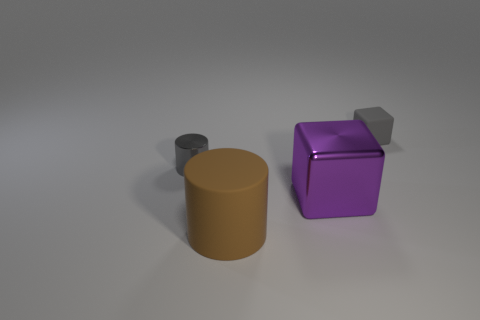Is the number of purple cubes behind the gray cube greater than the number of big metallic things behind the big purple object?
Keep it short and to the point. No. How many metal objects are either red spheres or cylinders?
Give a very brief answer. 1. There is a tiny thing that is the same color as the small matte cube; what is its material?
Offer a terse response. Metal. Are there fewer small gray objects that are behind the small rubber cube than gray metallic objects to the right of the gray metallic cylinder?
Your response must be concise. No. How many things are either cylinders or cylinders that are in front of the purple thing?
Offer a very short reply. 2. What is the material of the gray object that is the same size as the shiny cylinder?
Your answer should be very brief. Rubber. Are the large block and the brown cylinder made of the same material?
Provide a short and direct response. No. What is the color of the object that is both behind the metal cube and to the left of the small gray rubber block?
Provide a succinct answer. Gray. There is a matte object in front of the matte cube; does it have the same color as the small matte cube?
Your answer should be very brief. No. The gray thing that is the same size as the gray matte cube is what shape?
Provide a short and direct response. Cylinder. 